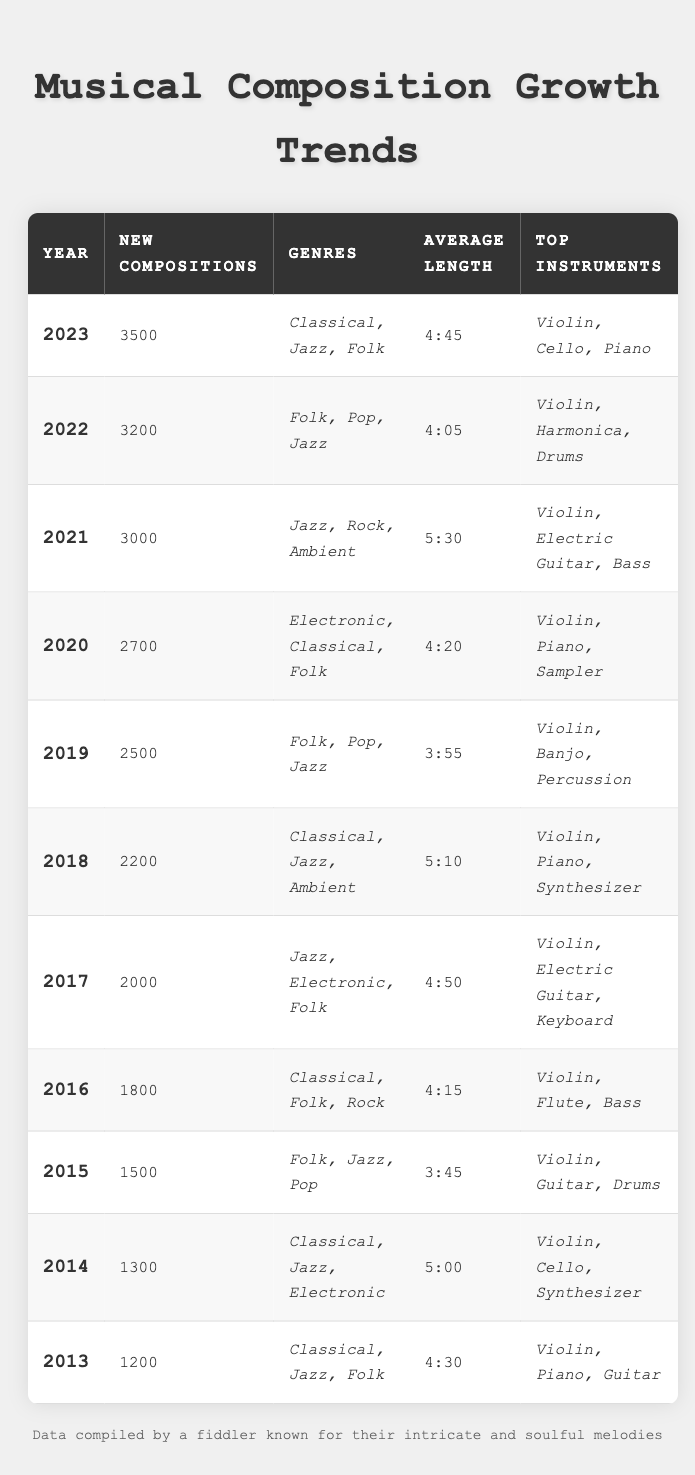What was the average length of compositions in the year 2021? In the table, the average length for 2021 is directly listed as 5:30.
Answer: 5:30 How many new compositions were created from 2013 to 2023? To find the total new compositions from 2013 to 2023, sum the values: 1200 + 1300 + 1500 + 1800 + 2000 + 2200 + 2500 + 2700 + 3000 + 3200 + 3500 = 20,000.
Answer: 20,000 Was the average length of compositions in 2022 longer than in 2019? The average length in 2022 is 4:05, while in 2019 it is 3:55, thus 4:05 is longer.
Answer: Yes Which year had the highest number of new compositions, and how many were there? The year with the highest count of new compositions is 2023 with 3500 new compositions.
Answer: 2023, 3500 What was the trend in the number of new compositions from 2013 to 2023? Starting with 1200 in 2013, new compositions increased each year, reaching 3500 in 2023, indicating a consistent growth trend.
Answer: Consistent growth In which year did the average length fall below 4 minutes? The only year with an average length of less than 4 minutes is 2015, which had an average length of 3:45.
Answer: 2015 How many genres were represented in the new compositions from 2016 to 2023? The genres of the years from 2016 to 2023 are Classical, Folk, Rock, Jazz, Electronic, Pop, and Ambient. The unique genres count is 7.
Answer: 7 What is the percentage increase in new compositions from 2013 (1200) to 2023 (3500)? To find the percentage increase: ((3500 - 1200) / 1200) * 100 = 191.67%.
Answer: 191.67% What was the most common top instrument used in compositions from 2013 to 2023? By reviewing data, the violin appears in every year from 2013 to 2023, making it the most common instrument.
Answer: Violin Did any year feature a genre that was not present the previous year? Yes, 2014 featured the Electronic genre, which was not present in 2013.
Answer: Yes 